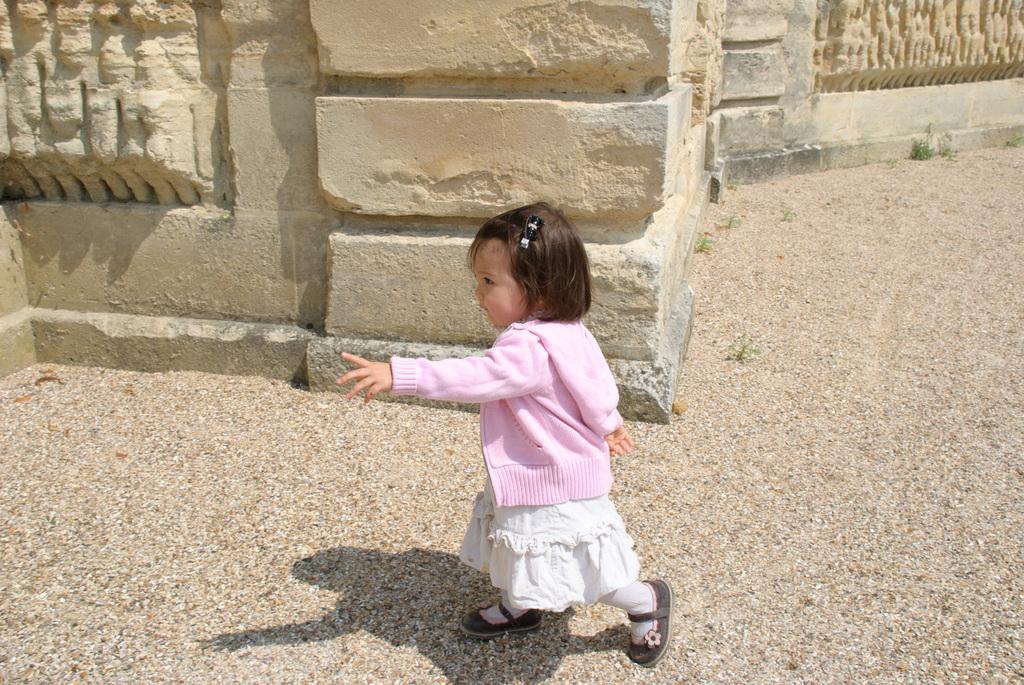In one or two sentences, can you explain what this image depicts? In this image, there is a floor, at the middle there is a small girl walking, she is wearing a pink color jacket, at the background there is a wall. 